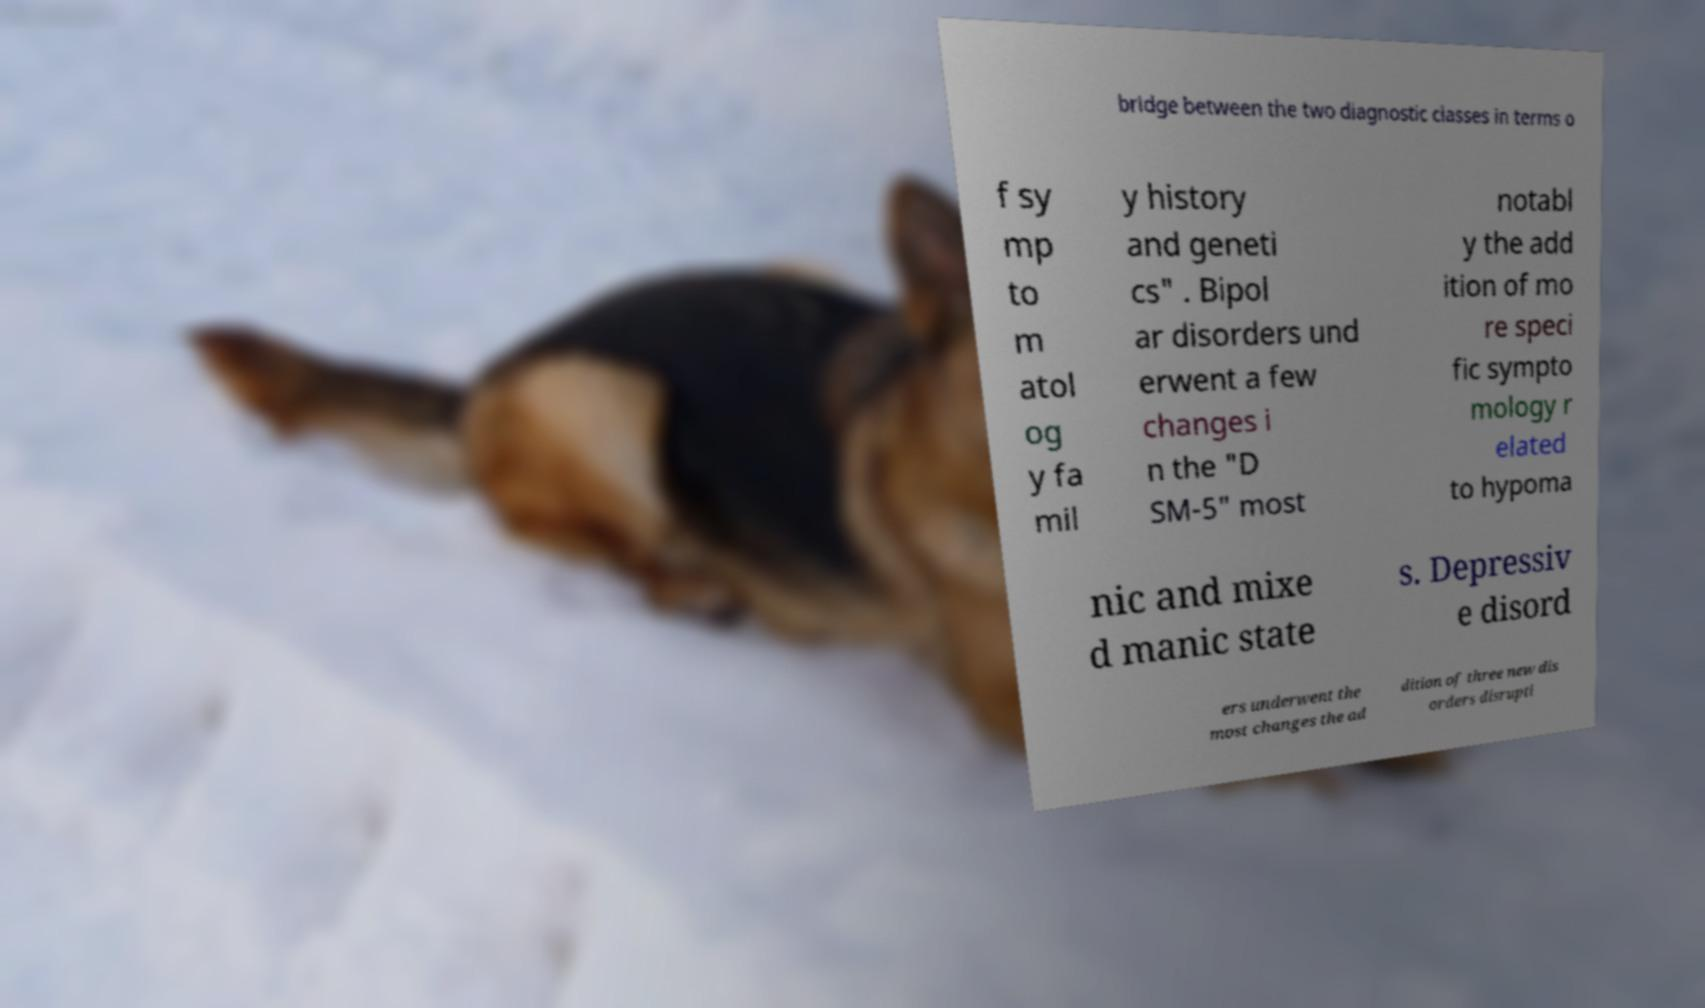There's text embedded in this image that I need extracted. Can you transcribe it verbatim? bridge between the two diagnostic classes in terms o f sy mp to m atol og y fa mil y history and geneti cs" . Bipol ar disorders und erwent a few changes i n the "D SM-5" most notabl y the add ition of mo re speci fic sympto mology r elated to hypoma nic and mixe d manic state s. Depressiv e disord ers underwent the most changes the ad dition of three new dis orders disrupti 